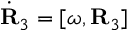<formula> <loc_0><loc_0><loc_500><loc_500>\dot { R } _ { 3 } = [ { \boldsymbol \omega } , { R } _ { 3 } ]</formula> 